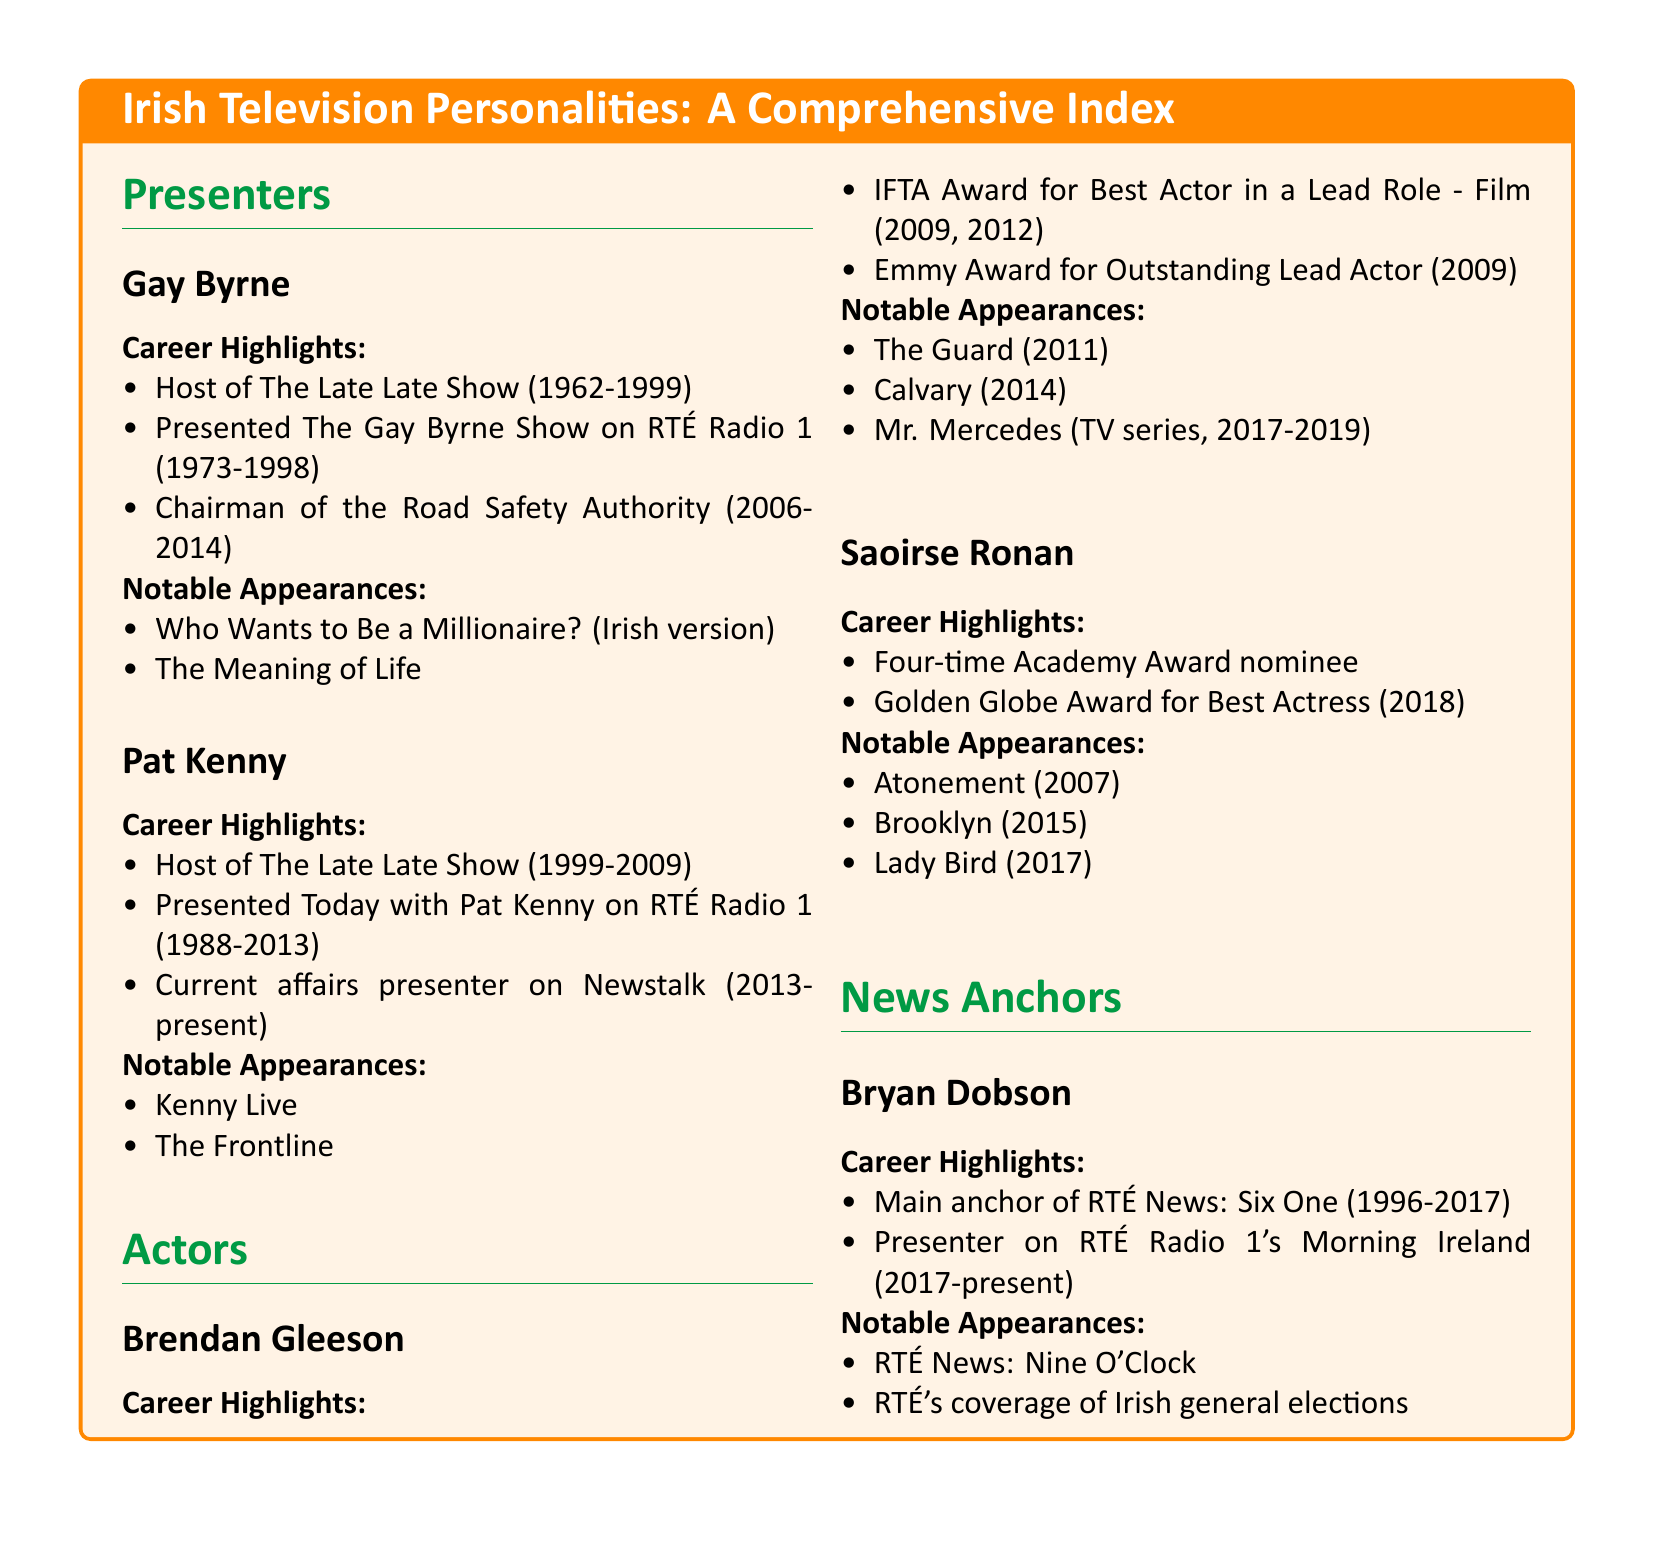What show did Gay Byrne host from 1962 to 1999? The document states that Gay Byrne was the host of The Late Late Show during that time period.
Answer: The Late Late Show What was Pat Kenny's role from 1999 to 2009? According to the document, Pat Kenny was the host of The Late Late Show during those years.
Answer: Host of The Late Late Show Which award did Brendan Gleeson win in 2009? The document mentions that Brendan Gleeson received the IFTA Award for Best Actor in a Lead Role in that year.
Answer: IFTA Award for Best Actor in a Lead Role How many Academy Award nominations has Saoirse Ronan received? The document indicates that she is a four-time Academy Award nominee.
Answer: Four What is the current role of Bryan Dobson as mentioned in the document? The document states that Bryan Dobson is a presenter on RTÉ Radio 1's Morning Ireland since 2017.
Answer: Presenter on RTÉ Radio 1's Morning Ireland Which show did Brendan Gleeson appear in that was released in 2014? The document lists Calvary as one of his notable appearances in that year.
Answer: Calvary What color is used for the section titles in the document? The document uses 'irishgreen' color for the section titles as specified.
Answer: irishgreen Who won the Golden Globe Award for Best Actress in 2018? According to the document, Saoirse Ronan won the Golden Globe Award for her performance that year.
Answer: Saoirse Ronan In what year did Bryan Dobson stop being the main anchor of RTÉ News: Six One? The document notes that he was the main anchor until 2017.
Answer: 2017 